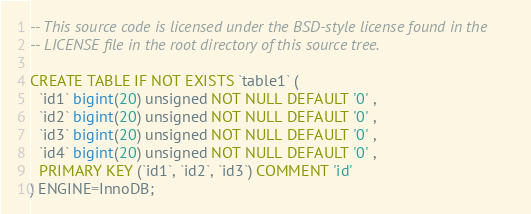Convert code to text. <code><loc_0><loc_0><loc_500><loc_500><_SQL_>-- This source code is licensed under the BSD-style license found in the
-- LICENSE file in the root directory of this source tree.

CREATE TABLE IF NOT EXISTS `table1` (
  `id1` bigint(20) unsigned NOT NULL DEFAULT '0' ,
  `id2` bigint(20) unsigned NOT NULL DEFAULT '0' ,
  `id3` bigint(20) unsigned NOT NULL DEFAULT '0' ,
  `id4` bigint(20) unsigned NOT NULL DEFAULT '0' ,
  PRIMARY KEY (`id1`, `id2`, `id3`) COMMENT 'id'
) ENGINE=InnoDB;
</code> 